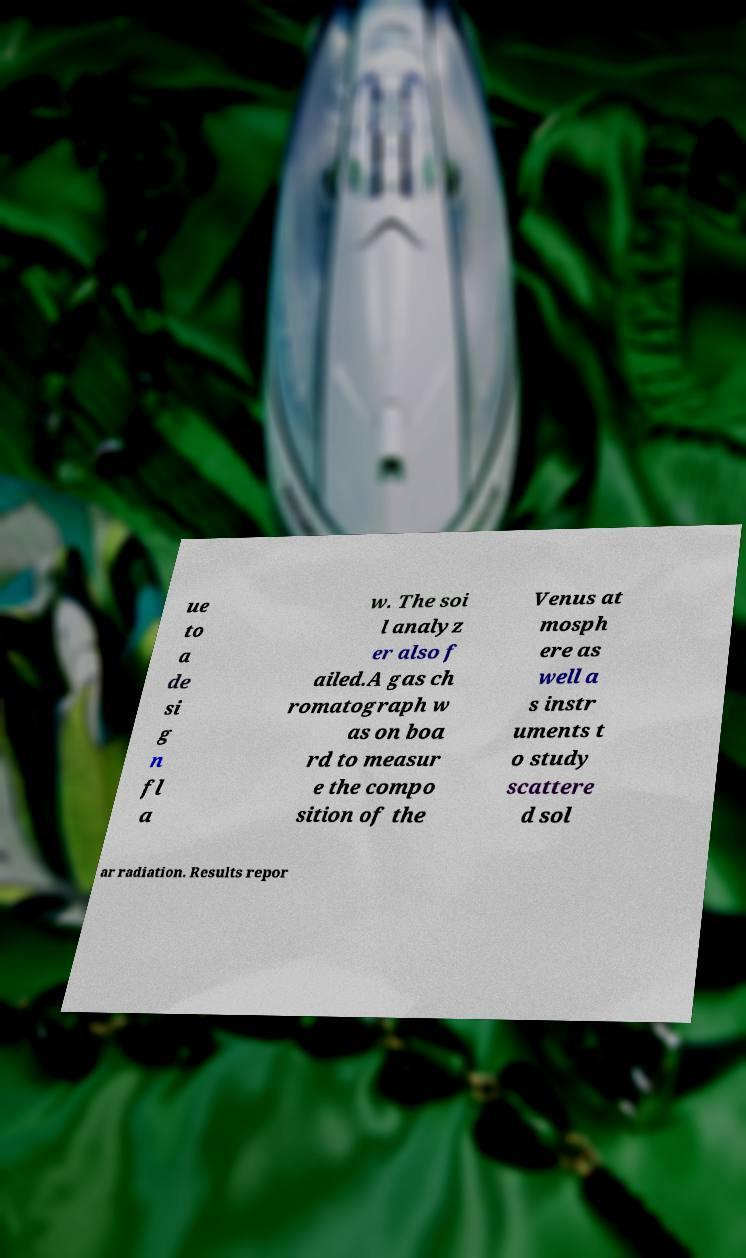Can you read and provide the text displayed in the image?This photo seems to have some interesting text. Can you extract and type it out for me? ue to a de si g n fl a w. The soi l analyz er also f ailed.A gas ch romatograph w as on boa rd to measur e the compo sition of the Venus at mosph ere as well a s instr uments t o study scattere d sol ar radiation. Results repor 